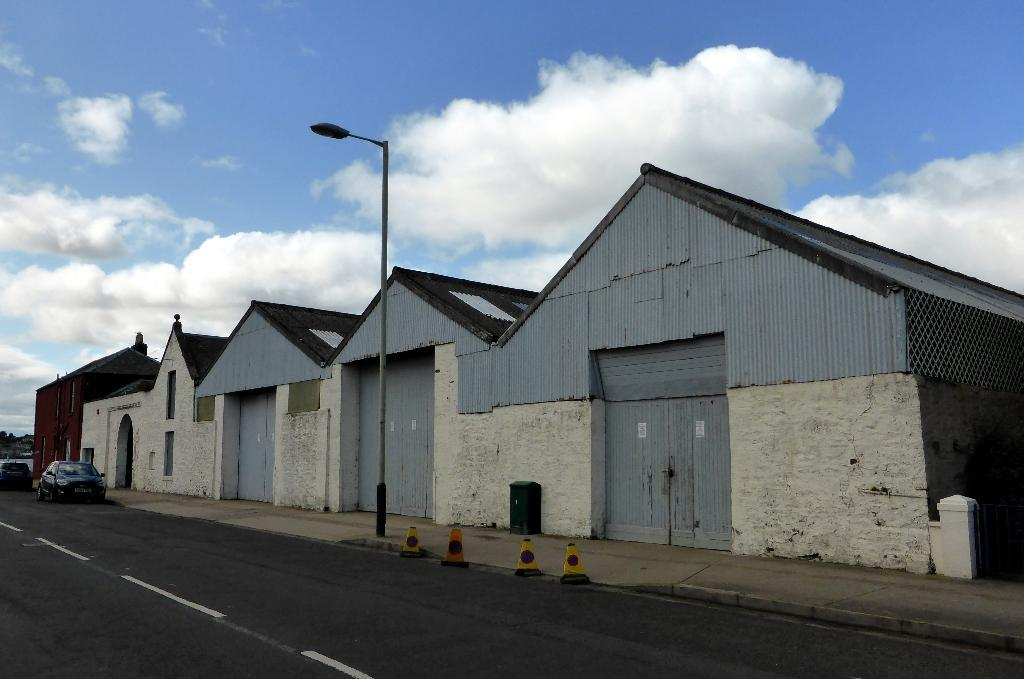What can be seen in the sky in the background of the image? There are clouds in the sky in the background of the image. What type of structures are present in the image? There are houses and rooftops in the image. What is the purpose of the street light in the image? The street light is likely for illuminating the area at night. What are the vehicles in the image used for? The vehicles in the image are likely used for transportation. What objects can be seen in the image? There are traffic cones on the road in the image. What type of door can be seen in the wilderness in the image? There is no door or wilderness present in the image. Who is the creator of the objects in the image? The creator of the objects in the image is not mentioned or visible in the image. 